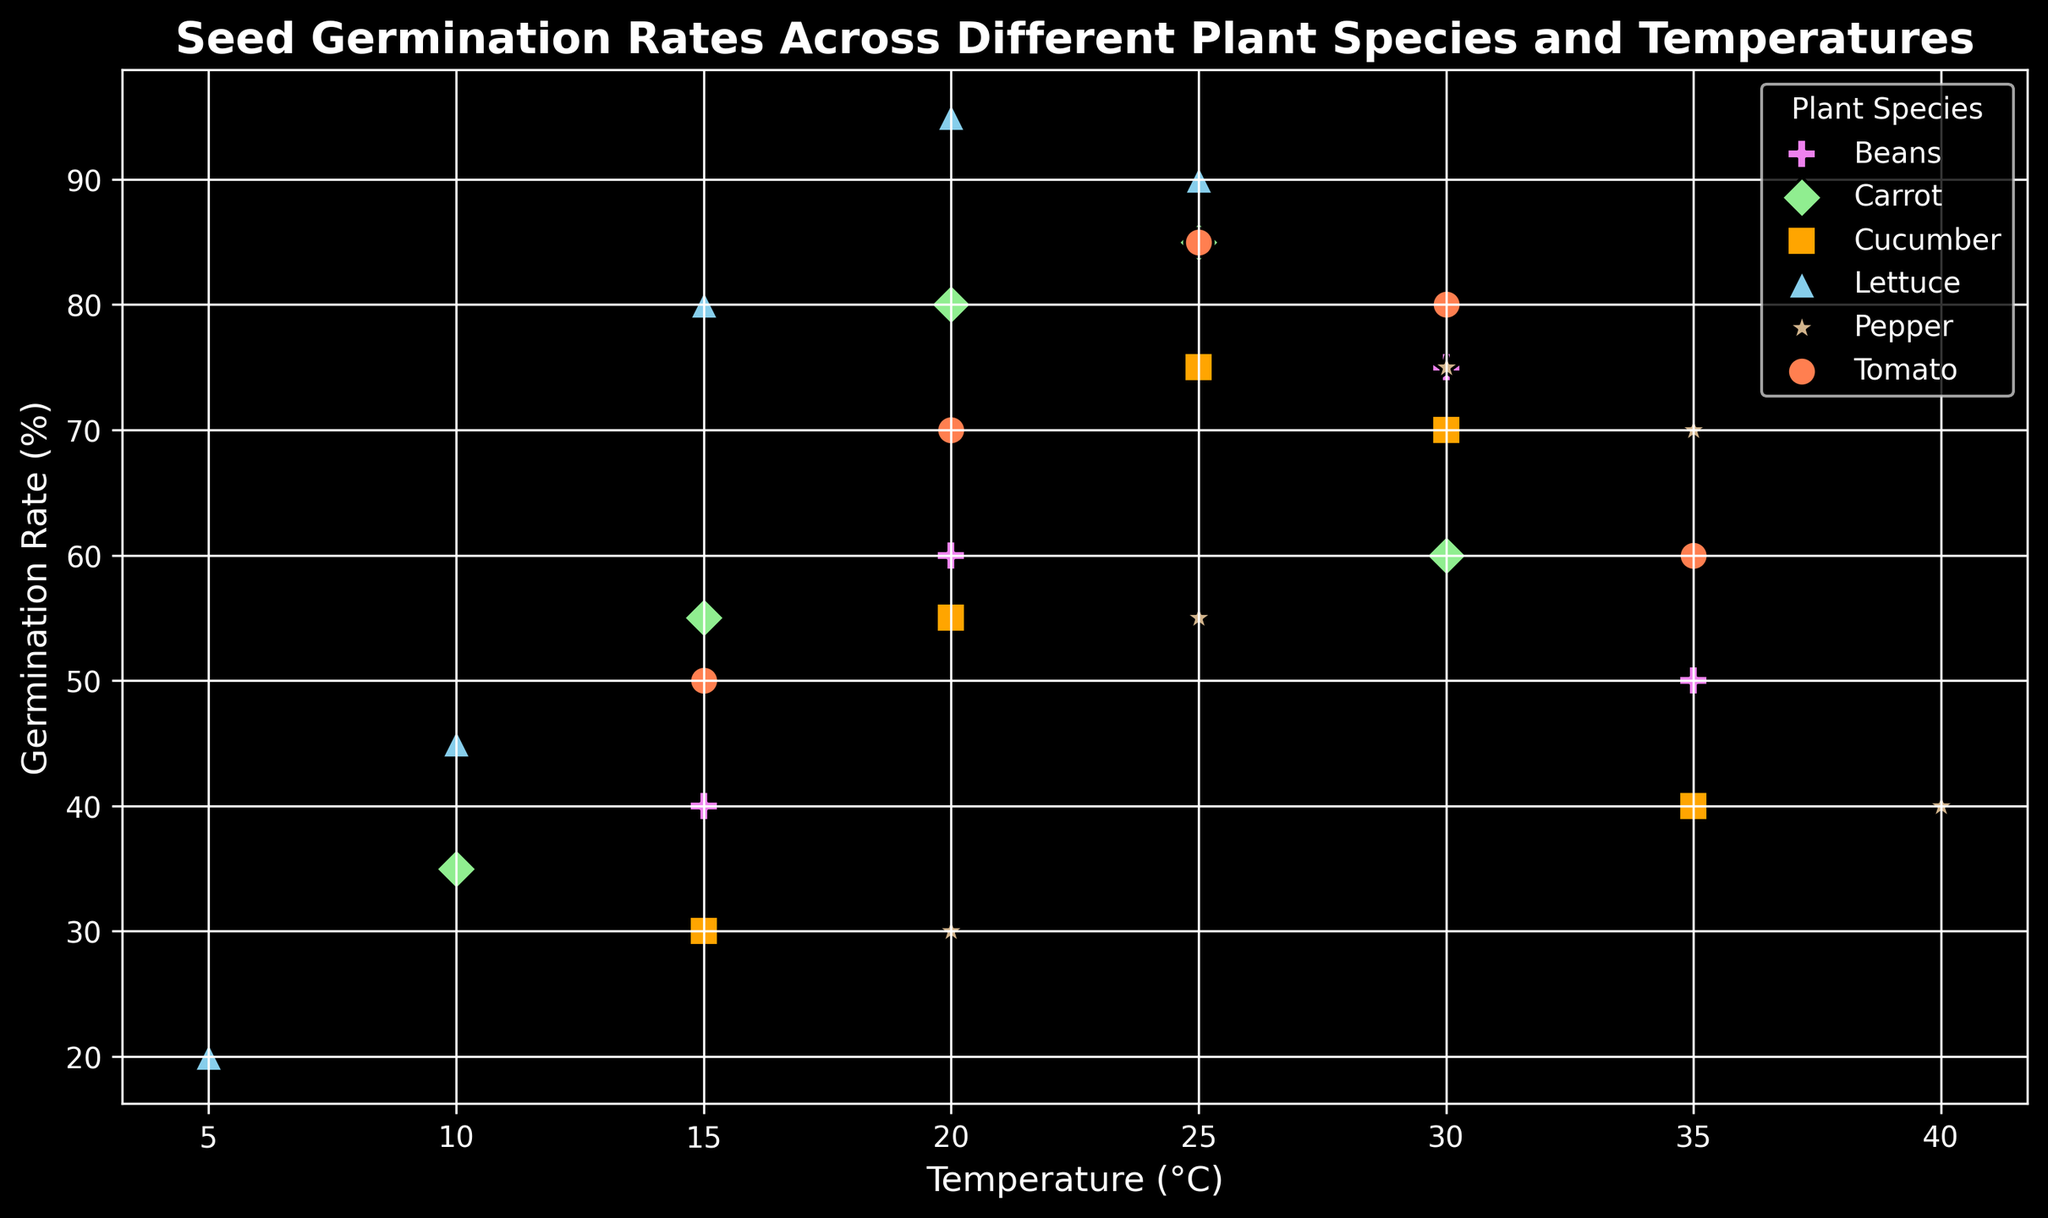Which plant has the highest germination rate at 25°C? Look at the data points plotted for each species at 25°C and compare their germination rates.
Answer: Lettuce What is the approximate difference in germination rate for Pepper between 25°C and 35°C? Find the germination rates for Pepper at 25°C and 35°C, which are 55% and 70%, respectively. Subtract the values: 70% - 55%.
Answer: 15% Which plant has the lowest germination rate at 15°C? Check the germination rates for all the species at 15°C: Tomato (50%), Lettuce (80%), Cucumber (30%), Carrot (55%), Beans (40%). Identify the lowest value.
Answer: Cucumber At which temperature does Tomato have the highest germination rate? Observe the germination rates for Tomato across all temperature points and note the highest value: 85% at 25°C.
Answer: 25°C How do the germination rates of Lettuce at 20°C compare to Beans at 20°C? Compare the germination rate of Lettuce at 20°C (95%) with that of Beans at 20°C (60%). Identify which is higher.
Answer: Lettuce has a higher germination rate What is the average germination rate for Carrot at temperatures of 10°C, 15°C, 20°C, and 25°C? Add the germination rates for Carrot at 10°C (35%), 15°C (55%), 20°C (80%), and 25°C (85%), then divide by 4. (35 + 55 + 80 + 85) / 4.
Answer: 63.75% Which plant species shows a decline in germination rate after 25°C? Look for species whose germination rates decrease after 25°C: Cucumber (75% to 70%), Beans (85% to 75%), Pepper (75% to 70%). Identify the ones that decline.
Answer: Cucumber, Beans, Pepper Between 15°C and 30°C, which plant has the least change in germination rate? Compare the germination rates and calculate the change for Tomato (30%), Lettuce (75%), Cucumber (40%), Carrot (30%), Beans (35%), Pepper (45%). Identify the smallest change.
Answer: Carrot How does the germination rate of Beans at 35°C compare to that at 15°C? Compare the rates of Beans at 35°C (50%) with that at 15°C (40%). Identify whether it increased or decreased and by how much.
Answer: Increased by 10% For which species is the difference in germination rate between 20°C and 25°C the greatest? Calculate the differences for each species between 20°C and 25°C: Tomato (15%), Lettuce (5%), Cucumber (20%), Carrot (5%), Beans (25%), Pepper (25%). Identify the greatest difference.
Answer: Beans, Pepper 